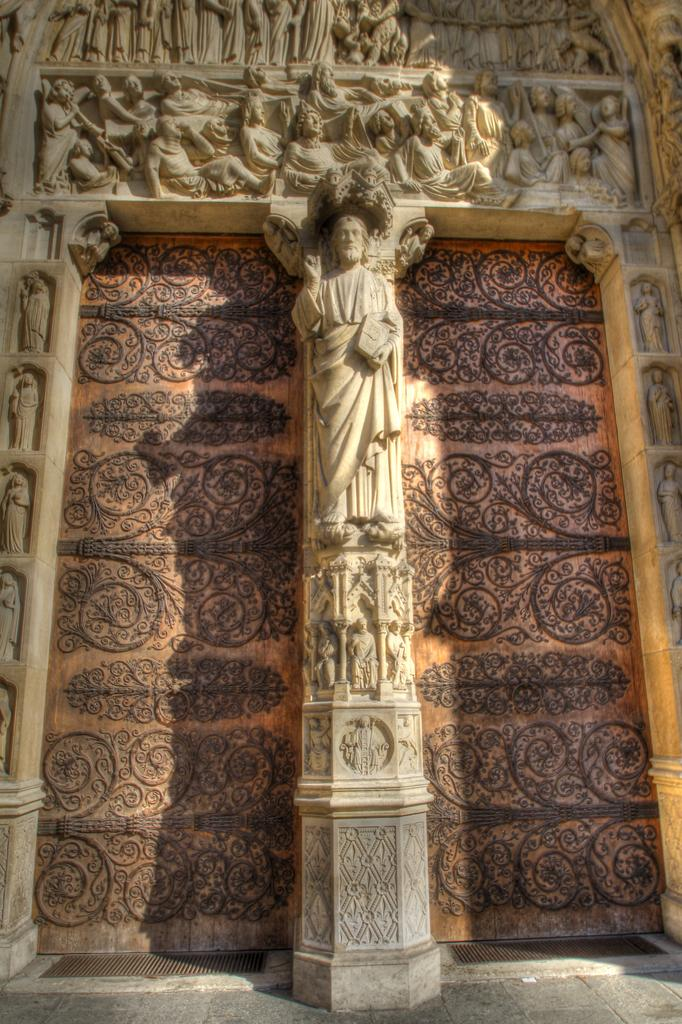What is present on the wall in the image? There are sculptures on the wall in the image. Can you describe the wall in the image? The wall is a main feature in the image. Is there a stream of water flowing near the sculptures in the image? No, there is no stream of water present in the image. Are the sculptures teaching a class in the image? No, the sculptures are not teaching a class in the image; they are stationary objects on the wall. 